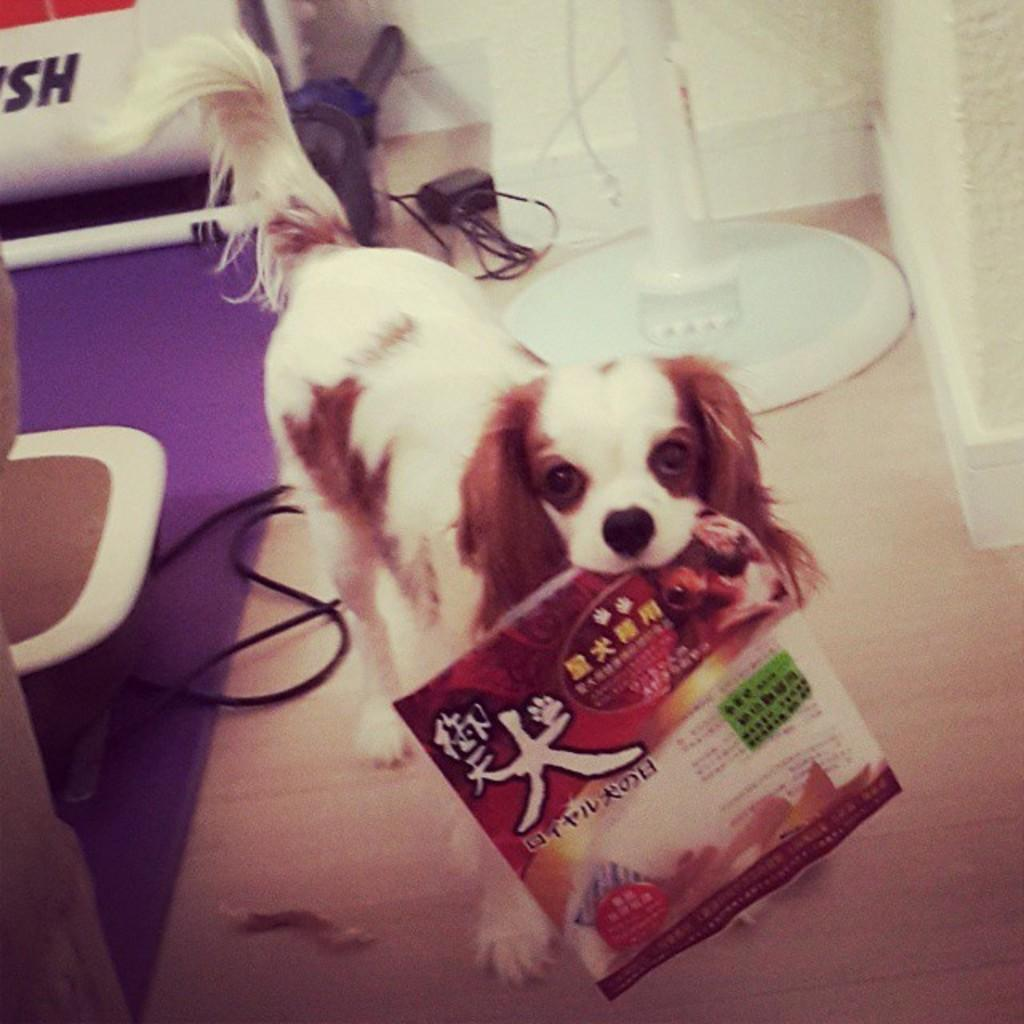What type of animal is present in the image? There is a dog in the image. What is the dog doing with its mouth? The dog is holding a book with its mouth. Where is the dog located in the image? The dog is on the floor. What can be seen in the background of the image? There is a stand, a group of cables, and chairs placed on the floor in the background of the image. What year is the amusement park guide referring to in the image? There is no amusement park guide or reference to a specific year in the image. 